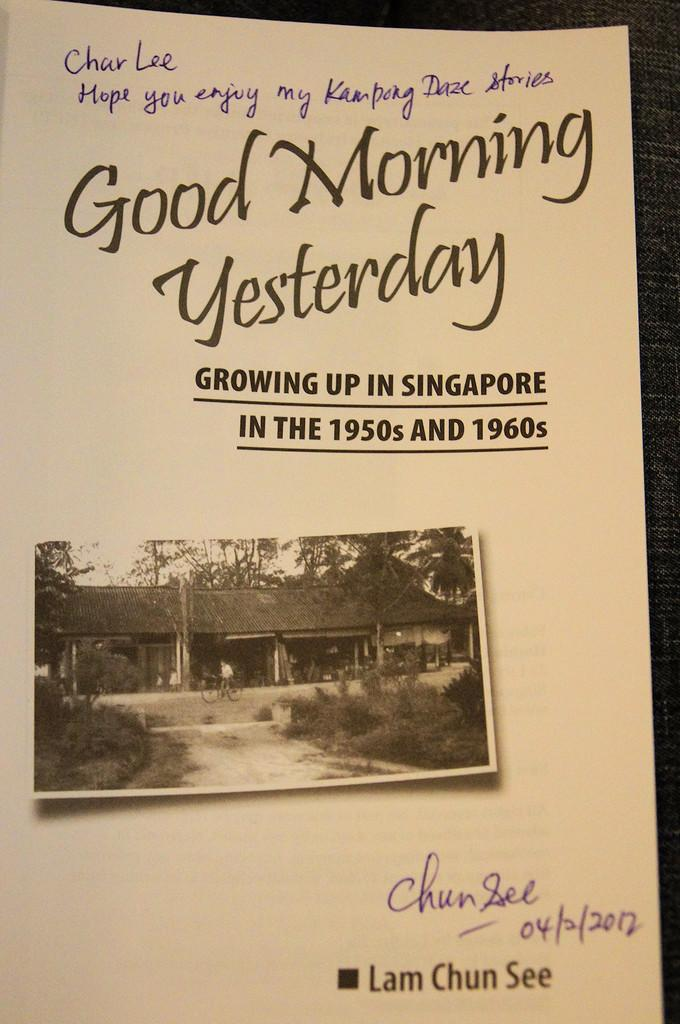<image>
Present a compact description of the photo's key features. Paper called Good Morning Yesterday autographed by the author. 